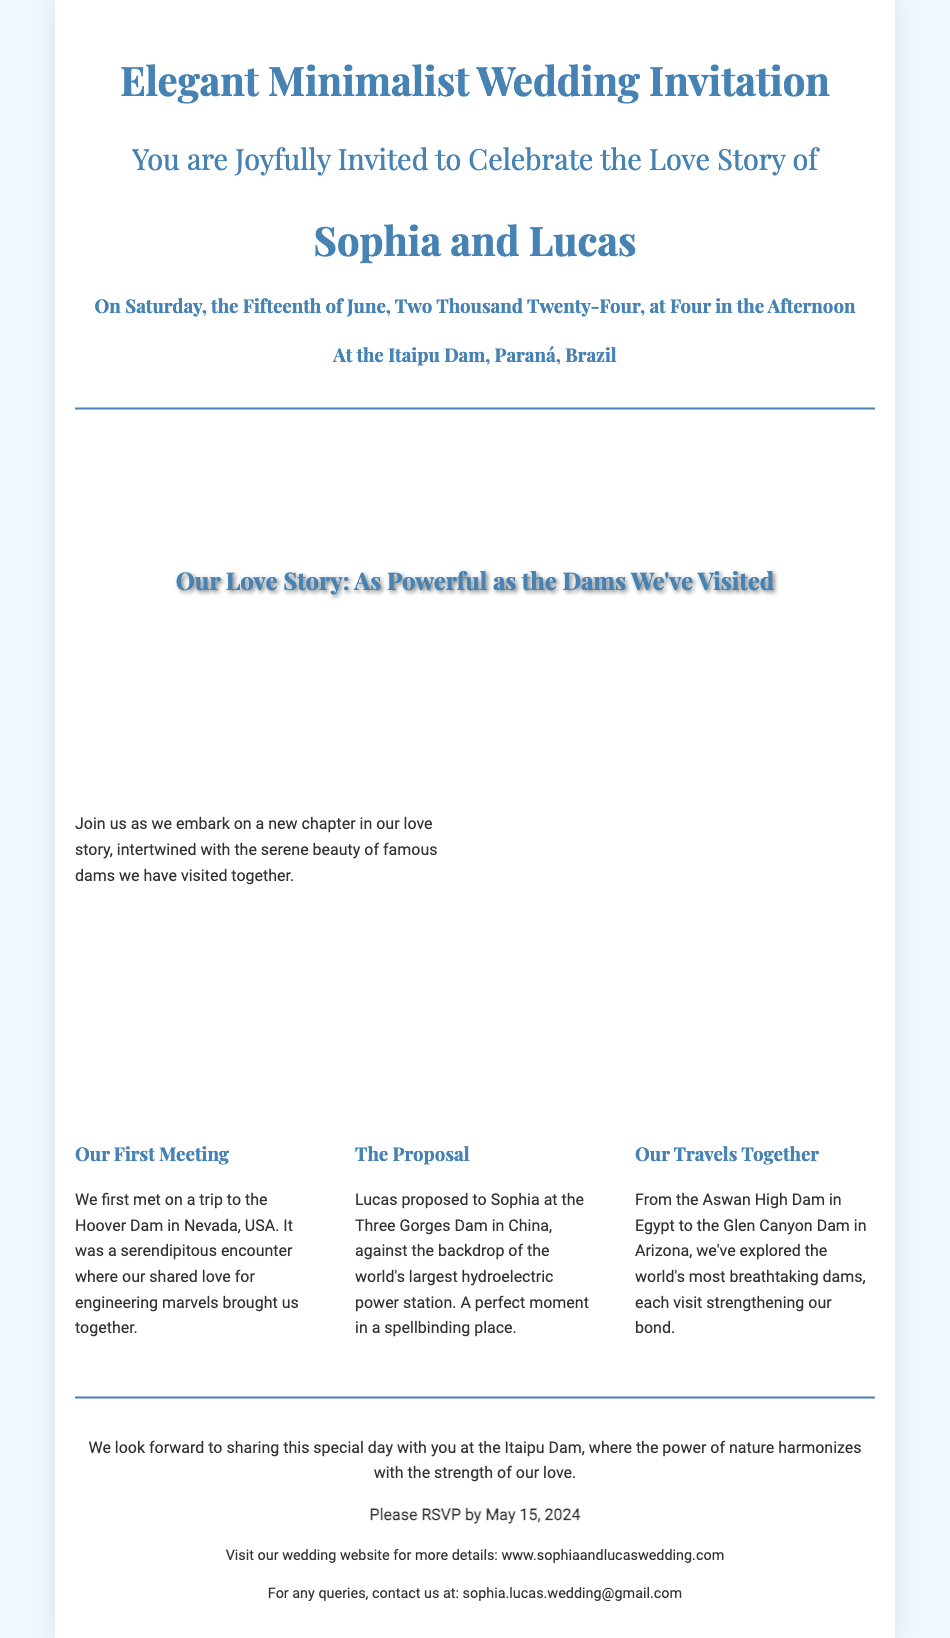What date is the wedding? The wedding date is explicitly mentioned in the invitation as Saturday, the Fifteenth of June, Two Thousand Twenty-Four.
Answer: June 15, 2024 Where is the wedding taking place? The location of the wedding is stated as at the Itaipu Dam, Paraná, Brazil.
Answer: Itaipu Dam, Paraná, Brazil Who are the couple getting married? The invitation clearly names the couple as Sophia and Lucas.
Answer: Sophia and Lucas What is highlighted in the cover photo section? The cover photo section mentions "Our Love Story: As Powerful as the Dams We've Visited."
Answer: Our Love Story: As Powerful as the Dams We've Visited What was the couple's first meeting location? The milestone section specifies that they first met at the Hoover Dam in Nevada, USA.
Answer: Hoover Dam, Nevada, USA What did Lucas do at the Three Gorges Dam? According to the document, Lucas proposed to Sophia at the Three Gorges Dam.
Answer: Proposed How many travel milestones are mentioned? The document describes three milestones in their love story related to their travels.
Answer: Three What should guests do by May 15, 2024? The RSVP deadline is specified, indicating what guests need to do by that date.
Answer: RSVP What is included in the additional information section? The additional information gives details about the wedding website and contact email for queries.
Answer: Wedding website and contact email 